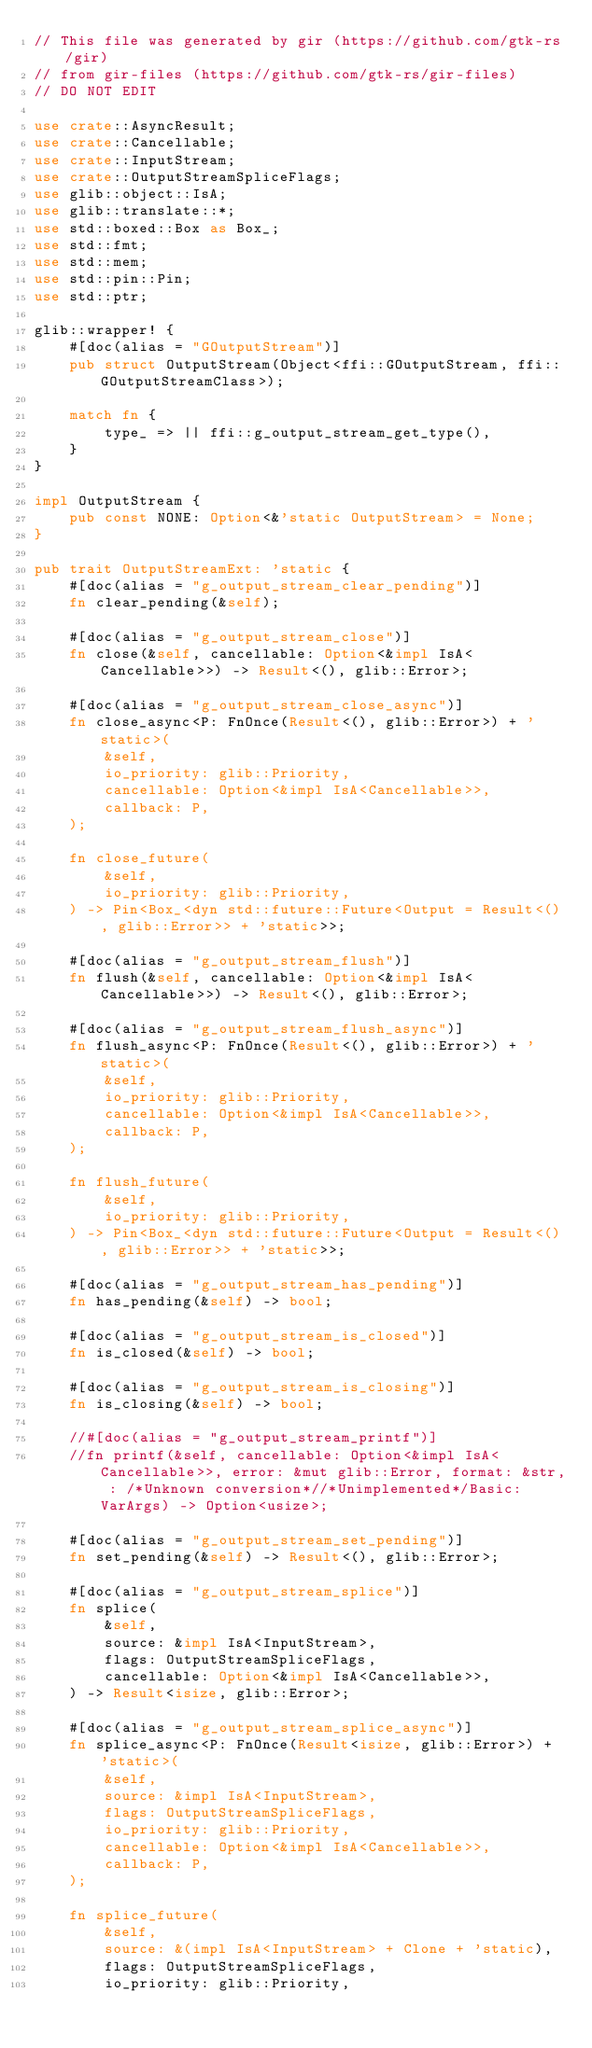Convert code to text. <code><loc_0><loc_0><loc_500><loc_500><_Rust_>// This file was generated by gir (https://github.com/gtk-rs/gir)
// from gir-files (https://github.com/gtk-rs/gir-files)
// DO NOT EDIT

use crate::AsyncResult;
use crate::Cancellable;
use crate::InputStream;
use crate::OutputStreamSpliceFlags;
use glib::object::IsA;
use glib::translate::*;
use std::boxed::Box as Box_;
use std::fmt;
use std::mem;
use std::pin::Pin;
use std::ptr;

glib::wrapper! {
    #[doc(alias = "GOutputStream")]
    pub struct OutputStream(Object<ffi::GOutputStream, ffi::GOutputStreamClass>);

    match fn {
        type_ => || ffi::g_output_stream_get_type(),
    }
}

impl OutputStream {
    pub const NONE: Option<&'static OutputStream> = None;
}

pub trait OutputStreamExt: 'static {
    #[doc(alias = "g_output_stream_clear_pending")]
    fn clear_pending(&self);

    #[doc(alias = "g_output_stream_close")]
    fn close(&self, cancellable: Option<&impl IsA<Cancellable>>) -> Result<(), glib::Error>;

    #[doc(alias = "g_output_stream_close_async")]
    fn close_async<P: FnOnce(Result<(), glib::Error>) + 'static>(
        &self,
        io_priority: glib::Priority,
        cancellable: Option<&impl IsA<Cancellable>>,
        callback: P,
    );

    fn close_future(
        &self,
        io_priority: glib::Priority,
    ) -> Pin<Box_<dyn std::future::Future<Output = Result<(), glib::Error>> + 'static>>;

    #[doc(alias = "g_output_stream_flush")]
    fn flush(&self, cancellable: Option<&impl IsA<Cancellable>>) -> Result<(), glib::Error>;

    #[doc(alias = "g_output_stream_flush_async")]
    fn flush_async<P: FnOnce(Result<(), glib::Error>) + 'static>(
        &self,
        io_priority: glib::Priority,
        cancellable: Option<&impl IsA<Cancellable>>,
        callback: P,
    );

    fn flush_future(
        &self,
        io_priority: glib::Priority,
    ) -> Pin<Box_<dyn std::future::Future<Output = Result<(), glib::Error>> + 'static>>;

    #[doc(alias = "g_output_stream_has_pending")]
    fn has_pending(&self) -> bool;

    #[doc(alias = "g_output_stream_is_closed")]
    fn is_closed(&self) -> bool;

    #[doc(alias = "g_output_stream_is_closing")]
    fn is_closing(&self) -> bool;

    //#[doc(alias = "g_output_stream_printf")]
    //fn printf(&self, cancellable: Option<&impl IsA<Cancellable>>, error: &mut glib::Error, format: &str, : /*Unknown conversion*//*Unimplemented*/Basic: VarArgs) -> Option<usize>;

    #[doc(alias = "g_output_stream_set_pending")]
    fn set_pending(&self) -> Result<(), glib::Error>;

    #[doc(alias = "g_output_stream_splice")]
    fn splice(
        &self,
        source: &impl IsA<InputStream>,
        flags: OutputStreamSpliceFlags,
        cancellable: Option<&impl IsA<Cancellable>>,
    ) -> Result<isize, glib::Error>;

    #[doc(alias = "g_output_stream_splice_async")]
    fn splice_async<P: FnOnce(Result<isize, glib::Error>) + 'static>(
        &self,
        source: &impl IsA<InputStream>,
        flags: OutputStreamSpliceFlags,
        io_priority: glib::Priority,
        cancellable: Option<&impl IsA<Cancellable>>,
        callback: P,
    );

    fn splice_future(
        &self,
        source: &(impl IsA<InputStream> + Clone + 'static),
        flags: OutputStreamSpliceFlags,
        io_priority: glib::Priority,</code> 